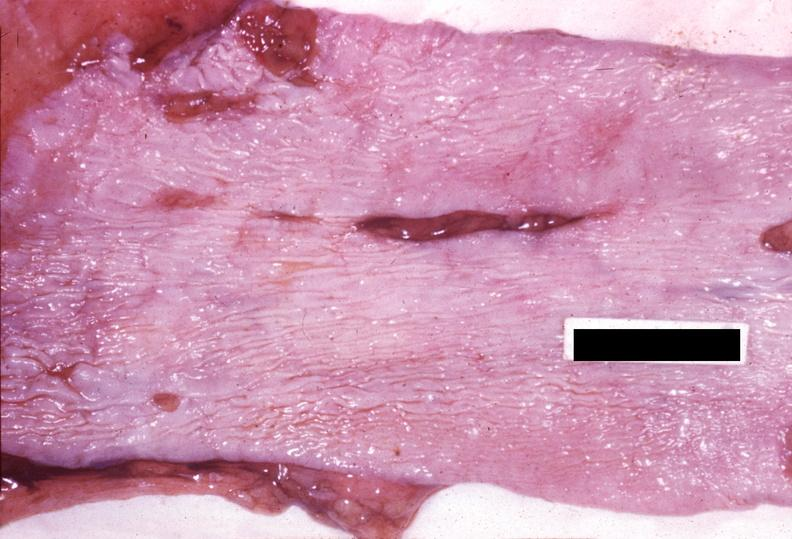what is present?
Answer the question using a single word or phrase. Gastrointestinal 